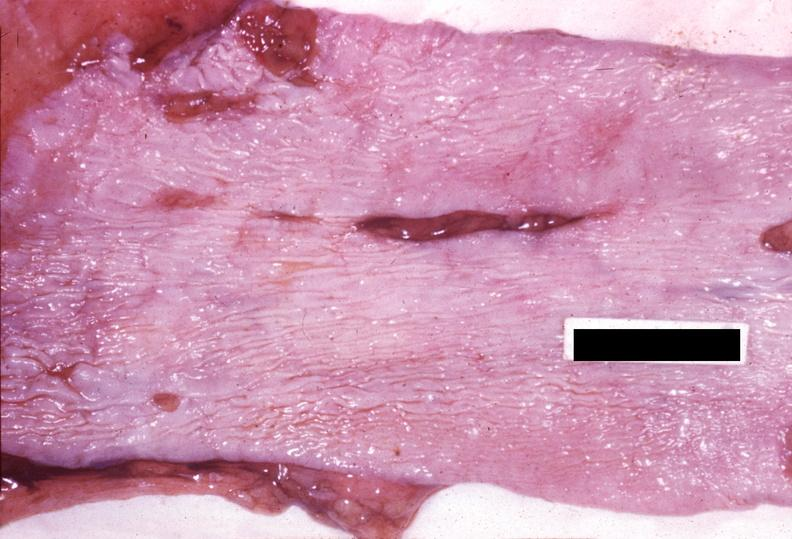what is present?
Answer the question using a single word or phrase. Gastrointestinal 